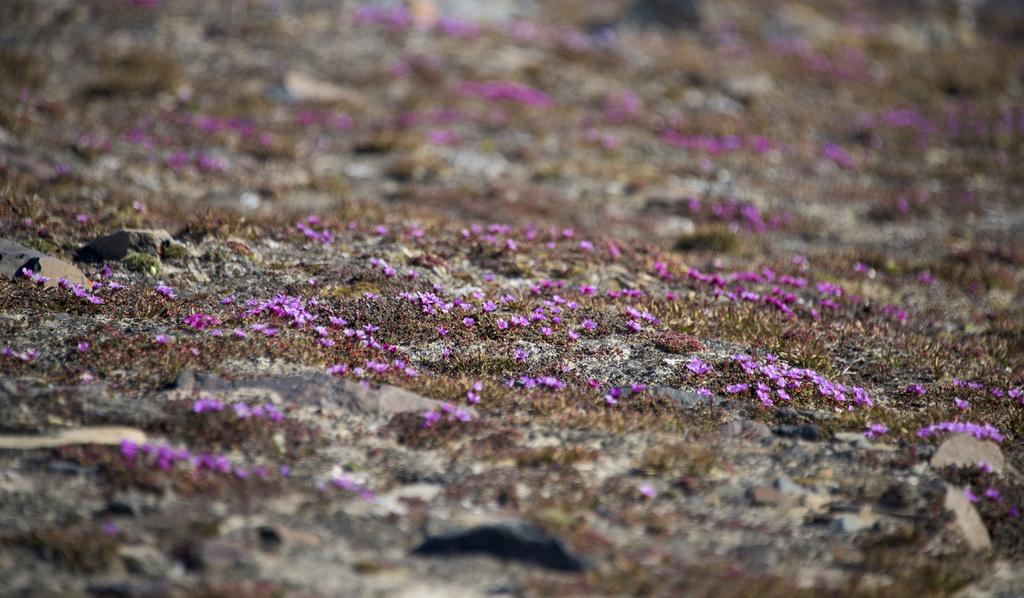What is located on the ground in the image? There is a group of flowers on the ground in the image. Can you describe the background of the image? The background of the image is blurred. What type of curtain can be seen hanging in the image? There is no curtain present in the image; it features a group of flowers on the ground and a blurred background. What type of quartz is visible in the image? There is no quartz present in the image. 